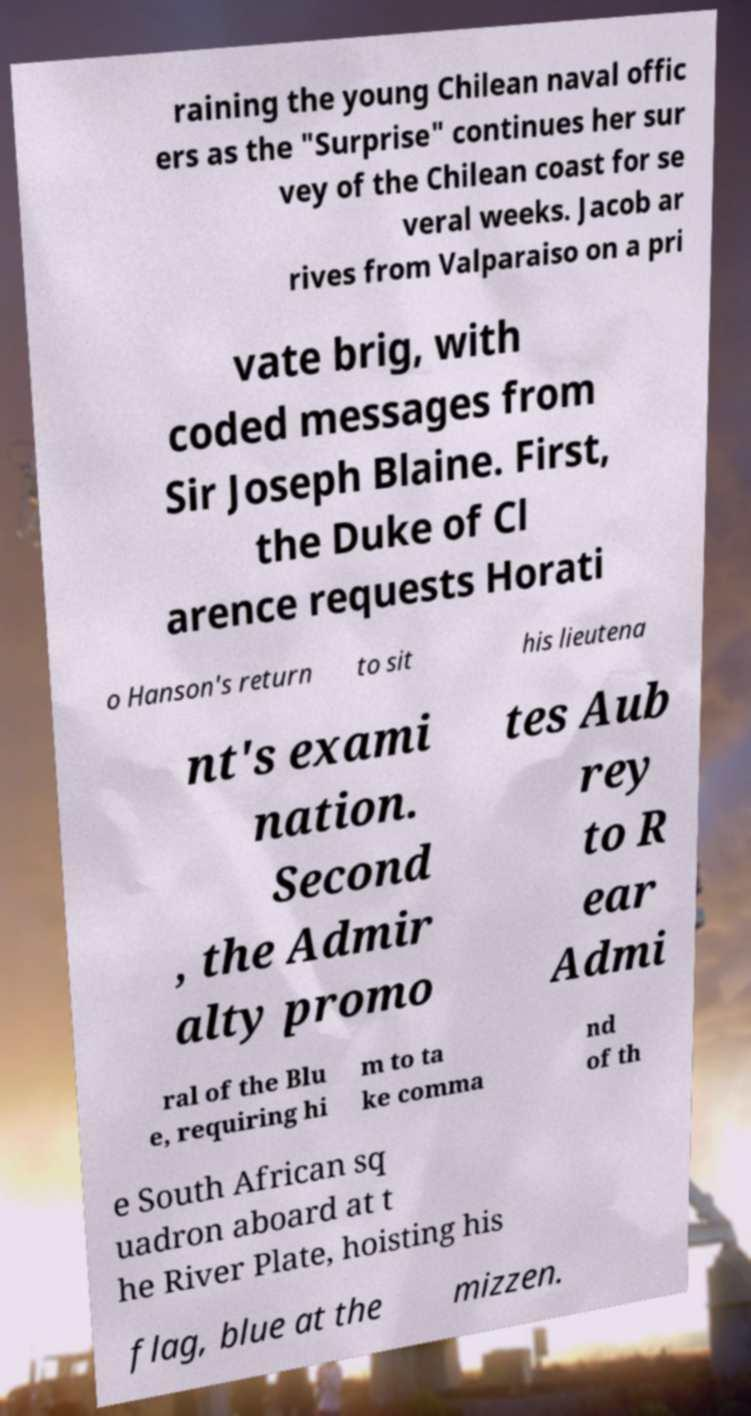There's text embedded in this image that I need extracted. Can you transcribe it verbatim? raining the young Chilean naval offic ers as the "Surprise" continues her sur vey of the Chilean coast for se veral weeks. Jacob ar rives from Valparaiso on a pri vate brig, with coded messages from Sir Joseph Blaine. First, the Duke of Cl arence requests Horati o Hanson's return to sit his lieutena nt's exami nation. Second , the Admir alty promo tes Aub rey to R ear Admi ral of the Blu e, requiring hi m to ta ke comma nd of th e South African sq uadron aboard at t he River Plate, hoisting his flag, blue at the mizzen. 